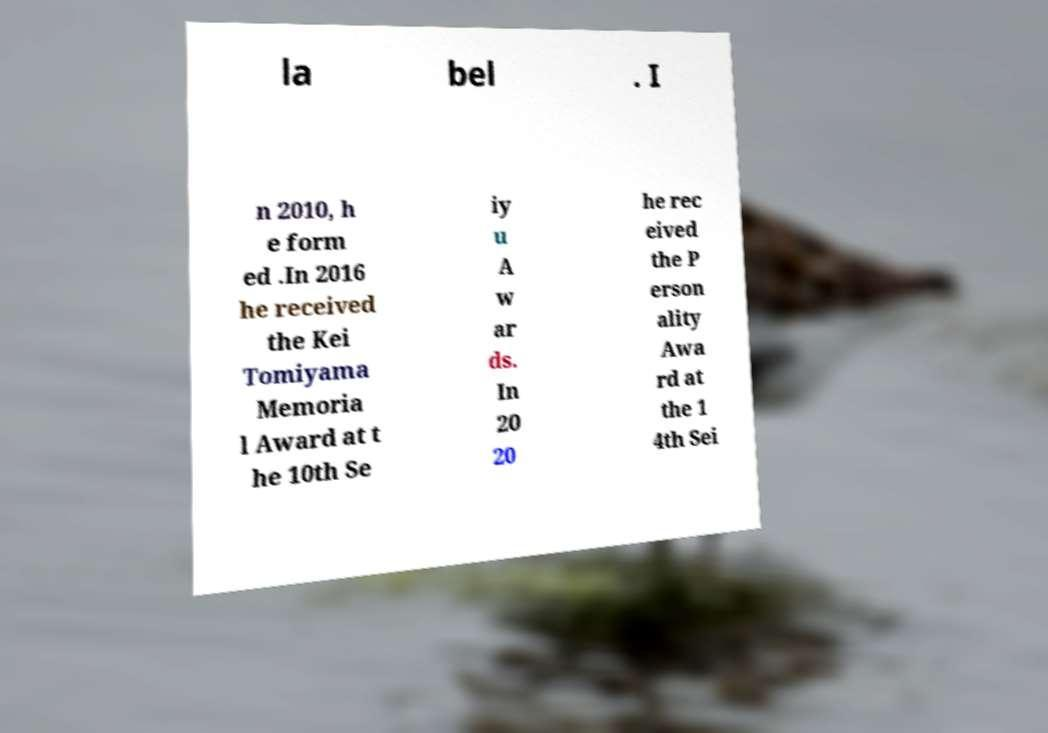Could you assist in decoding the text presented in this image and type it out clearly? la bel . I n 2010, h e form ed .In 2016 he received the Kei Tomiyama Memoria l Award at t he 10th Se iy u A w ar ds. In 20 20 he rec eived the P erson ality Awa rd at the 1 4th Sei 